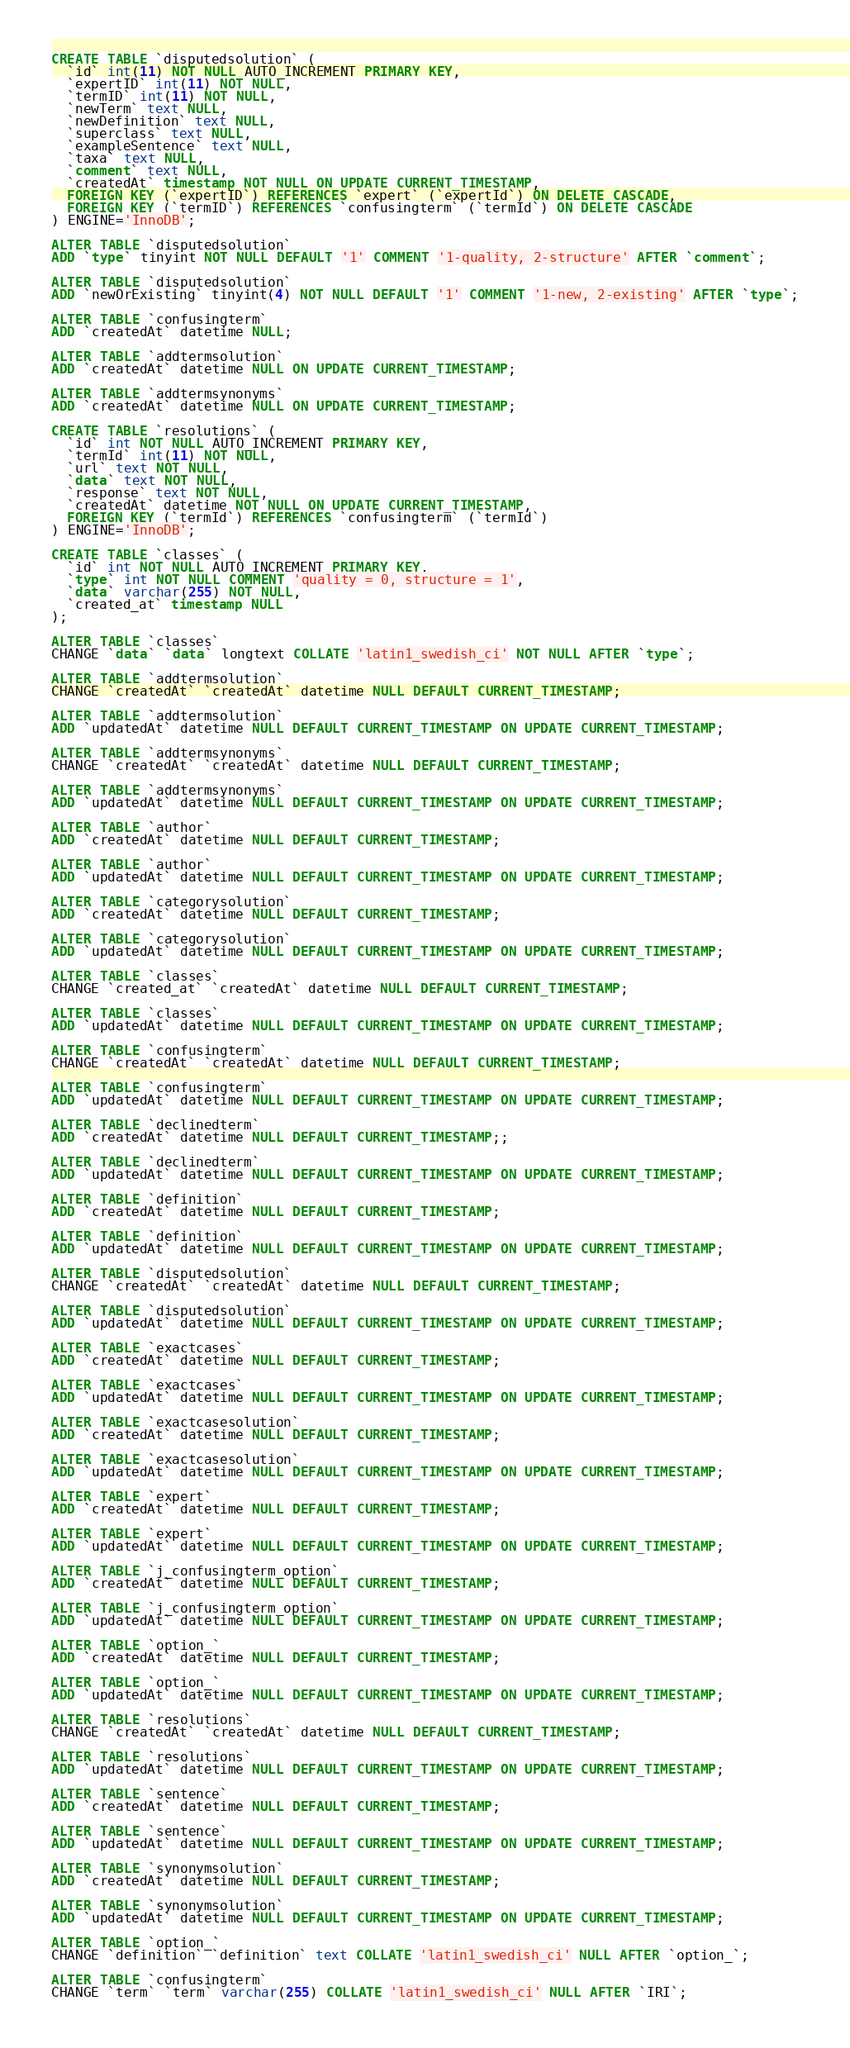Convert code to text. <code><loc_0><loc_0><loc_500><loc_500><_SQL_>CREATE TABLE `disputedsolution` (
  `id` int(11) NOT NULL AUTO_INCREMENT PRIMARY KEY,
  `expertID` int(11) NOT NULL,
  `termID` int(11) NOT NULL,
  `newTerm` text NULL,
  `newDefinition` text NULL,
  `superclass` text NULL,
  `exampleSentence` text NULL,
  `taxa` text NULL,
  `comment` text NULL,
  `createdAt` timestamp NOT NULL ON UPDATE CURRENT_TIMESTAMP,
  FOREIGN KEY (`expertID`) REFERENCES `expert` (`expertId`) ON DELETE CASCADE,
  FOREIGN KEY (`termID`) REFERENCES `confusingterm` (`termId`) ON DELETE CASCADE
) ENGINE='InnoDB';

ALTER TABLE `disputedsolution`
ADD `type` tinyint NOT NULL DEFAULT '1' COMMENT '1-quality, 2-structure' AFTER `comment`;

ALTER TABLE `disputedsolution`
ADD `newOrExisting` tinyint(4) NOT NULL DEFAULT '1' COMMENT '1-new, 2-existing' AFTER `type`;

ALTER TABLE `confusingterm`
ADD `createdAt` datetime NULL;

ALTER TABLE `addtermsolution`
ADD `createdAt` datetime NULL ON UPDATE CURRENT_TIMESTAMP;

ALTER TABLE `addtermsynonyms`
ADD `createdAt` datetime NULL ON UPDATE CURRENT_TIMESTAMP;

CREATE TABLE `resolutions` (
  `id` int NOT NULL AUTO_INCREMENT PRIMARY KEY,
  `termId` int(11) NOT NULL,
  `url` text NOT NULL,
  `data` text NOT NULL,
  `response` text NOT NULL,
  `createdAt` datetime NOT NULL ON UPDATE CURRENT_TIMESTAMP,
  FOREIGN KEY (`termId`) REFERENCES `confusingterm` (`termId`)
) ENGINE='InnoDB';

CREATE TABLE `classes` (
  `id` int NOT NULL AUTO_INCREMENT PRIMARY KEY,
  `type` int NOT NULL COMMENT 'quality = 0, structure = 1',
  `data` varchar(255) NOT NULL,
  `created_at` timestamp NULL
);

ALTER TABLE `classes`
CHANGE `data` `data` longtext COLLATE 'latin1_swedish_ci' NOT NULL AFTER `type`;

ALTER TABLE `addtermsolution`
CHANGE `createdAt` `createdAt` datetime NULL DEFAULT CURRENT_TIMESTAMP;

ALTER TABLE `addtermsolution`
ADD `updatedAt` datetime NULL DEFAULT CURRENT_TIMESTAMP ON UPDATE CURRENT_TIMESTAMP;

ALTER TABLE `addtermsynonyms`
CHANGE `createdAt` `createdAt` datetime NULL DEFAULT CURRENT_TIMESTAMP;

ALTER TABLE `addtermsynonyms`
ADD `updatedAt` datetime NULL DEFAULT CURRENT_TIMESTAMP ON UPDATE CURRENT_TIMESTAMP;

ALTER TABLE `author`
ADD `createdAt` datetime NULL DEFAULT CURRENT_TIMESTAMP;

ALTER TABLE `author`
ADD `updatedAt` datetime NULL DEFAULT CURRENT_TIMESTAMP ON UPDATE CURRENT_TIMESTAMP;

ALTER TABLE `categorysolution`
ADD `createdAt` datetime NULL DEFAULT CURRENT_TIMESTAMP;

ALTER TABLE `categorysolution`
ADD `updatedAt` datetime NULL DEFAULT CURRENT_TIMESTAMP ON UPDATE CURRENT_TIMESTAMP;

ALTER TABLE `classes`
CHANGE `created_at` `createdAt` datetime NULL DEFAULT CURRENT_TIMESTAMP;

ALTER TABLE `classes`
ADD `updatedAt` datetime NULL DEFAULT CURRENT_TIMESTAMP ON UPDATE CURRENT_TIMESTAMP;

ALTER TABLE `confusingterm`
CHANGE `createdAt` `createdAt` datetime NULL DEFAULT CURRENT_TIMESTAMP;

ALTER TABLE `confusingterm`
ADD `updatedAt` datetime NULL DEFAULT CURRENT_TIMESTAMP ON UPDATE CURRENT_TIMESTAMP;

ALTER TABLE `declinedterm`
ADD `createdAt` datetime NULL DEFAULT CURRENT_TIMESTAMP;;

ALTER TABLE `declinedterm`
ADD `updatedAt` datetime NULL DEFAULT CURRENT_TIMESTAMP ON UPDATE CURRENT_TIMESTAMP;

ALTER TABLE `definition`
ADD `createdAt` datetime NULL DEFAULT CURRENT_TIMESTAMP;

ALTER TABLE `definition`
ADD `updatedAt` datetime NULL DEFAULT CURRENT_TIMESTAMP ON UPDATE CURRENT_TIMESTAMP;

ALTER TABLE `disputedsolution`
CHANGE `createdAt` `createdAt` datetime NULL DEFAULT CURRENT_TIMESTAMP;

ALTER TABLE `disputedsolution`
ADD `updatedAt` datetime NULL DEFAULT CURRENT_TIMESTAMP ON UPDATE CURRENT_TIMESTAMP;

ALTER TABLE `exactcases`
ADD `createdAt` datetime NULL DEFAULT CURRENT_TIMESTAMP;

ALTER TABLE `exactcases`
ADD `updatedAt` datetime NULL DEFAULT CURRENT_TIMESTAMP ON UPDATE CURRENT_TIMESTAMP;

ALTER TABLE `exactcasesolution`
ADD `createdAt` datetime NULL DEFAULT CURRENT_TIMESTAMP;

ALTER TABLE `exactcasesolution`
ADD `updatedAt` datetime NULL DEFAULT CURRENT_TIMESTAMP ON UPDATE CURRENT_TIMESTAMP;

ALTER TABLE `expert`
ADD `createdAt` datetime NULL DEFAULT CURRENT_TIMESTAMP;

ALTER TABLE `expert`
ADD `updatedAt` datetime NULL DEFAULT CURRENT_TIMESTAMP ON UPDATE CURRENT_TIMESTAMP;

ALTER TABLE `j_confusingterm_option`
ADD `createdAt` datetime NULL DEFAULT CURRENT_TIMESTAMP;

ALTER TABLE `j_confusingterm_option`
ADD `updatedAt` datetime NULL DEFAULT CURRENT_TIMESTAMP ON UPDATE CURRENT_TIMESTAMP;

ALTER TABLE `option_`
ADD `createdAt` datetime NULL DEFAULT CURRENT_TIMESTAMP;

ALTER TABLE `option_`
ADD `updatedAt` datetime NULL DEFAULT CURRENT_TIMESTAMP ON UPDATE CURRENT_TIMESTAMP;

ALTER TABLE `resolutions`
CHANGE `createdAt` `createdAt` datetime NULL DEFAULT CURRENT_TIMESTAMP;

ALTER TABLE `resolutions`
ADD `updatedAt` datetime NULL DEFAULT CURRENT_TIMESTAMP ON UPDATE CURRENT_TIMESTAMP;

ALTER TABLE `sentence`
ADD `createdAt` datetime NULL DEFAULT CURRENT_TIMESTAMP;

ALTER TABLE `sentence`
ADD `updatedAt` datetime NULL DEFAULT CURRENT_TIMESTAMP ON UPDATE CURRENT_TIMESTAMP;

ALTER TABLE `synonymsolution`
ADD `createdAt` datetime NULL DEFAULT CURRENT_TIMESTAMP;

ALTER TABLE `synonymsolution`
ADD `updatedAt` datetime NULL DEFAULT CURRENT_TIMESTAMP ON UPDATE CURRENT_TIMESTAMP;

ALTER TABLE `option_`
CHANGE `definition` `definition` text COLLATE 'latin1_swedish_ci' NULL AFTER `option_`;

ALTER TABLE `confusingterm`
CHANGE `term` `term` varchar(255) COLLATE 'latin1_swedish_ci' NULL AFTER `IRI`;</code> 